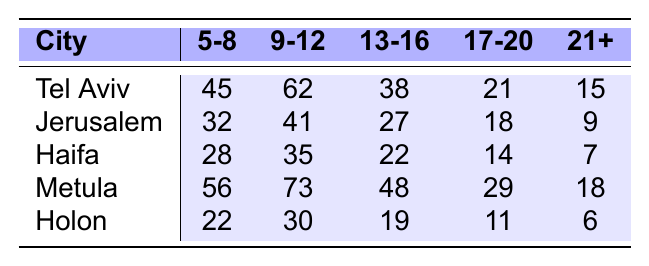What is the highest enrollment rate among age groups in Tel Aviv? The highest enrollment in Tel Aviv is in the age group 9-12 with 62 participants.
Answer: 62 Which city has the lowest enrollment rate in the 21+ age group? Holon has the lowest enrollment in the 21+ age group with 6 participants.
Answer: 6 What is the total enrollment for the 5-8 age group across all cities? Adding the enrollments: 45 (Tel Aviv) + 32 (Jerusalem) + 28 (Haifa) + 56 (Metula) + 22 (Holon) = 183.
Answer: 183 In which age group does Metula have the highest enrollment? Metula has the highest enrollment in the 9-12 age group with 73 participants.
Answer: 73 Is there a city where the 17-20 age group has more participants than the 13-16 age group? Yes, Tel Aviv has 21 participants in the 17-20 age group, while the 13-16 age group has 38 participants; hence, it does not have more participants.
Answer: No What is the difference in enrollment between the 9-12 age group in Tel Aviv and Holon? Tel Aviv has 62 participants, Holon has 30; the difference is 62 - 30 = 32.
Answer: 32 Which age group has the least participation in Haifa? The least participation in Haifa is in the 21+ age group with 7 participants.
Answer: 7 When comparing the age groups 5-8 and 9-12, which group has a higher total enrollment across all cities combined? For 5-8: 45 + 32 + 28 + 56 + 22 = 183 and for 9-12: 62 + 41 + 35 + 73 + 30 = 241. The 9-12 age group has a higher total.
Answer: 9-12 What is the average enrollment for the 13-16 age group across all cities? The sum for 13-16 is 38 + 27 + 22 + 48 + 19 = 154, and there are 5 cities, so the average is 154/5 = 30.8.
Answer: 30.8 Does Jerusalem have a higher total enrollment than Haifa? Total enrollment for Jerusalem is 32 + 41 + 27 + 18 + 9 = 127; for Haifa, it's 28 + 35 + 22 + 14 + 7 = 106. Thus, Jerusalem has a higher total.
Answer: Yes 